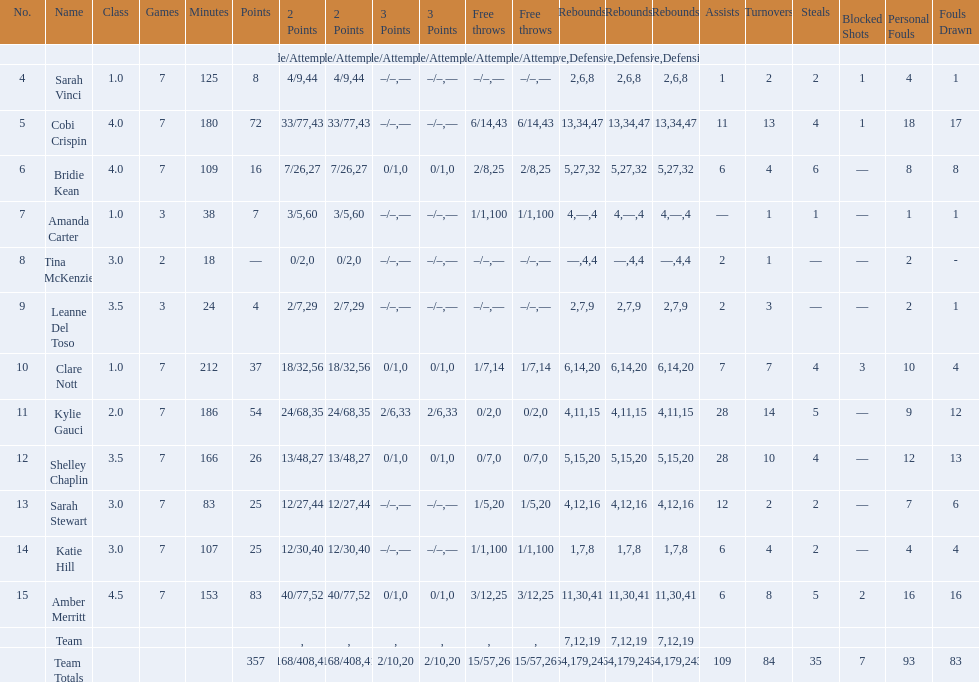Who acquired the most steals among all players? Bridie Kean. 